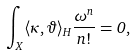<formula> <loc_0><loc_0><loc_500><loc_500>\int _ { X } \langle \kappa , \vartheta \rangle _ { H } \frac { \omega ^ { n } } { n ! } = 0 ,</formula> 